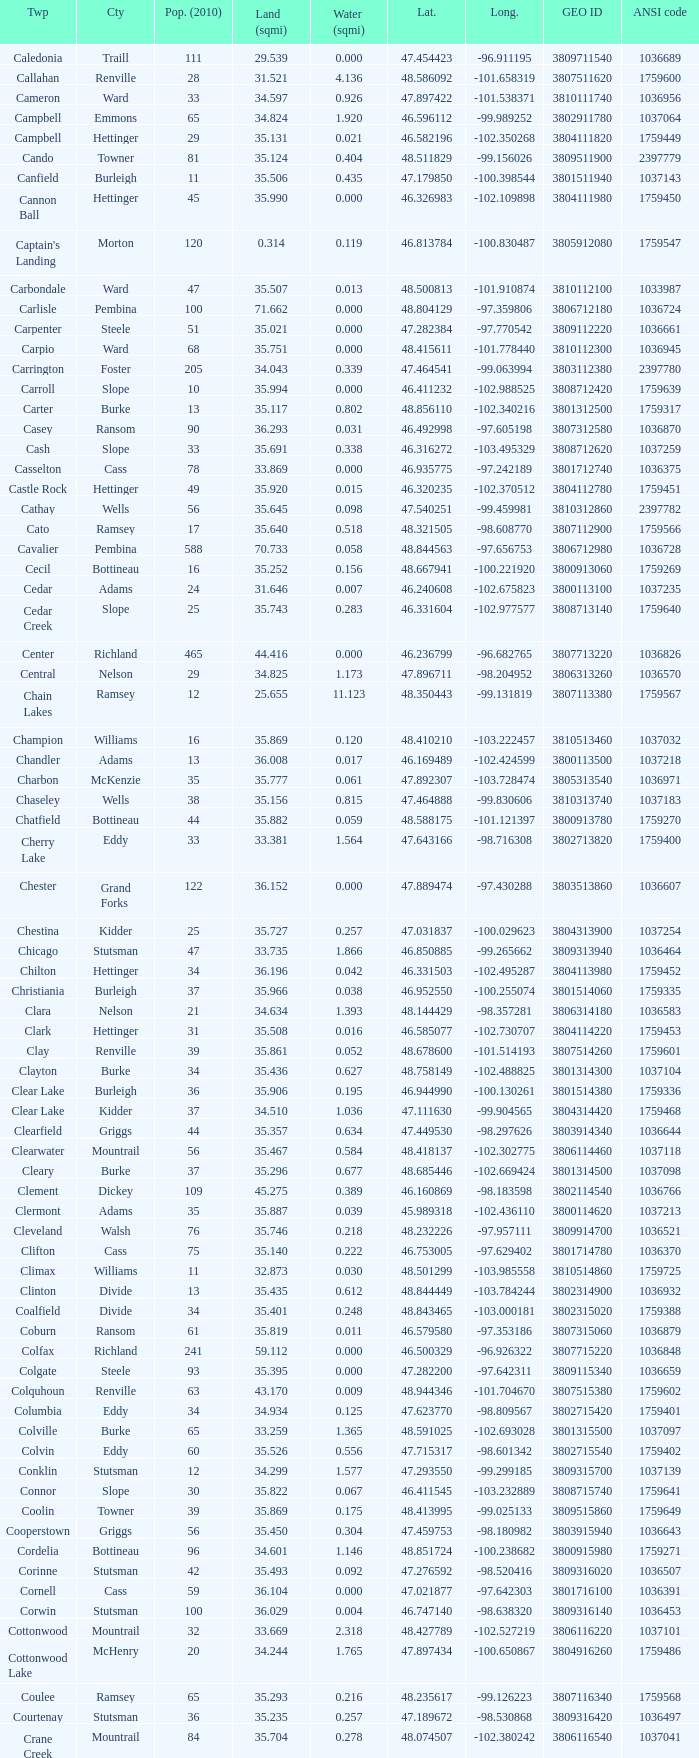What was the latitude of the Clearwater townsship? 48.418137. Give me the full table as a dictionary. {'header': ['Twp', 'Cty', 'Pop. (2010)', 'Land (sqmi)', 'Water (sqmi)', 'Lat.', 'Long.', 'GEO ID', 'ANSI code'], 'rows': [['Caledonia', 'Traill', '111', '29.539', '0.000', '47.454423', '-96.911195', '3809711540', '1036689'], ['Callahan', 'Renville', '28', '31.521', '4.136', '48.586092', '-101.658319', '3807511620', '1759600'], ['Cameron', 'Ward', '33', '34.597', '0.926', '47.897422', '-101.538371', '3810111740', '1036956'], ['Campbell', 'Emmons', '65', '34.824', '1.920', '46.596112', '-99.989252', '3802911780', '1037064'], ['Campbell', 'Hettinger', '29', '35.131', '0.021', '46.582196', '-102.350268', '3804111820', '1759449'], ['Cando', 'Towner', '81', '35.124', '0.404', '48.511829', '-99.156026', '3809511900', '2397779'], ['Canfield', 'Burleigh', '11', '35.506', '0.435', '47.179850', '-100.398544', '3801511940', '1037143'], ['Cannon Ball', 'Hettinger', '45', '35.990', '0.000', '46.326983', '-102.109898', '3804111980', '1759450'], ["Captain's Landing", 'Morton', '120', '0.314', '0.119', '46.813784', '-100.830487', '3805912080', '1759547'], ['Carbondale', 'Ward', '47', '35.507', '0.013', '48.500813', '-101.910874', '3810112100', '1033987'], ['Carlisle', 'Pembina', '100', '71.662', '0.000', '48.804129', '-97.359806', '3806712180', '1036724'], ['Carpenter', 'Steele', '51', '35.021', '0.000', '47.282384', '-97.770542', '3809112220', '1036661'], ['Carpio', 'Ward', '68', '35.751', '0.000', '48.415611', '-101.778440', '3810112300', '1036945'], ['Carrington', 'Foster', '205', '34.043', '0.339', '47.464541', '-99.063994', '3803112380', '2397780'], ['Carroll', 'Slope', '10', '35.994', '0.000', '46.411232', '-102.988525', '3808712420', '1759639'], ['Carter', 'Burke', '13', '35.117', '0.802', '48.856110', '-102.340216', '3801312500', '1759317'], ['Casey', 'Ransom', '90', '36.293', '0.031', '46.492998', '-97.605198', '3807312580', '1036870'], ['Cash', 'Slope', '33', '35.691', '0.338', '46.316272', '-103.495329', '3808712620', '1037259'], ['Casselton', 'Cass', '78', '33.869', '0.000', '46.935775', '-97.242189', '3801712740', '1036375'], ['Castle Rock', 'Hettinger', '49', '35.920', '0.015', '46.320235', '-102.370512', '3804112780', '1759451'], ['Cathay', 'Wells', '56', '35.645', '0.098', '47.540251', '-99.459981', '3810312860', '2397782'], ['Cato', 'Ramsey', '17', '35.640', '0.518', '48.321505', '-98.608770', '3807112900', '1759566'], ['Cavalier', 'Pembina', '588', '70.733', '0.058', '48.844563', '-97.656753', '3806712980', '1036728'], ['Cecil', 'Bottineau', '16', '35.252', '0.156', '48.667941', '-100.221920', '3800913060', '1759269'], ['Cedar', 'Adams', '24', '31.646', '0.007', '46.240608', '-102.675823', '3800113100', '1037235'], ['Cedar Creek', 'Slope', '25', '35.743', '0.283', '46.331604', '-102.977577', '3808713140', '1759640'], ['Center', 'Richland', '465', '44.416', '0.000', '46.236799', '-96.682765', '3807713220', '1036826'], ['Central', 'Nelson', '29', '34.825', '1.173', '47.896711', '-98.204952', '3806313260', '1036570'], ['Chain Lakes', 'Ramsey', '12', '25.655', '11.123', '48.350443', '-99.131819', '3807113380', '1759567'], ['Champion', 'Williams', '16', '35.869', '0.120', '48.410210', '-103.222457', '3810513460', '1037032'], ['Chandler', 'Adams', '13', '36.008', '0.017', '46.169489', '-102.424599', '3800113500', '1037218'], ['Charbon', 'McKenzie', '35', '35.777', '0.061', '47.892307', '-103.728474', '3805313540', '1036971'], ['Chaseley', 'Wells', '38', '35.156', '0.815', '47.464888', '-99.830606', '3810313740', '1037183'], ['Chatfield', 'Bottineau', '44', '35.882', '0.059', '48.588175', '-101.121397', '3800913780', '1759270'], ['Cherry Lake', 'Eddy', '33', '33.381', '1.564', '47.643166', '-98.716308', '3802713820', '1759400'], ['Chester', 'Grand Forks', '122', '36.152', '0.000', '47.889474', '-97.430288', '3803513860', '1036607'], ['Chestina', 'Kidder', '25', '35.727', '0.257', '47.031837', '-100.029623', '3804313900', '1037254'], ['Chicago', 'Stutsman', '47', '33.735', '1.866', '46.850885', '-99.265662', '3809313940', '1036464'], ['Chilton', 'Hettinger', '34', '36.196', '0.042', '46.331503', '-102.495287', '3804113980', '1759452'], ['Christiania', 'Burleigh', '37', '35.966', '0.038', '46.952550', '-100.255074', '3801514060', '1759335'], ['Clara', 'Nelson', '21', '34.634', '1.393', '48.144429', '-98.357281', '3806314180', '1036583'], ['Clark', 'Hettinger', '31', '35.508', '0.016', '46.585077', '-102.730707', '3804114220', '1759453'], ['Clay', 'Renville', '39', '35.861', '0.052', '48.678600', '-101.514193', '3807514260', '1759601'], ['Clayton', 'Burke', '34', '35.436', '0.627', '48.758149', '-102.488825', '3801314300', '1037104'], ['Clear Lake', 'Burleigh', '36', '35.906', '0.195', '46.944990', '-100.130261', '3801514380', '1759336'], ['Clear Lake', 'Kidder', '37', '34.510', '1.036', '47.111630', '-99.904565', '3804314420', '1759468'], ['Clearfield', 'Griggs', '44', '35.357', '0.634', '47.449530', '-98.297626', '3803914340', '1036644'], ['Clearwater', 'Mountrail', '56', '35.467', '0.584', '48.418137', '-102.302775', '3806114460', '1037118'], ['Cleary', 'Burke', '37', '35.296', '0.677', '48.685446', '-102.669424', '3801314500', '1037098'], ['Clement', 'Dickey', '109', '45.275', '0.389', '46.160869', '-98.183598', '3802114540', '1036766'], ['Clermont', 'Adams', '35', '35.887', '0.039', '45.989318', '-102.436110', '3800114620', '1037213'], ['Cleveland', 'Walsh', '76', '35.746', '0.218', '48.232226', '-97.957111', '3809914700', '1036521'], ['Clifton', 'Cass', '75', '35.140', '0.222', '46.753005', '-97.629402', '3801714780', '1036370'], ['Climax', 'Williams', '11', '32.873', '0.030', '48.501299', '-103.985558', '3810514860', '1759725'], ['Clinton', 'Divide', '13', '35.435', '0.612', '48.844449', '-103.784244', '3802314900', '1036932'], ['Coalfield', 'Divide', '34', '35.401', '0.248', '48.843465', '-103.000181', '3802315020', '1759388'], ['Coburn', 'Ransom', '61', '35.819', '0.011', '46.579580', '-97.353186', '3807315060', '1036879'], ['Colfax', 'Richland', '241', '59.112', '0.000', '46.500329', '-96.926322', '3807715220', '1036848'], ['Colgate', 'Steele', '93', '35.395', '0.000', '47.282200', '-97.642311', '3809115340', '1036659'], ['Colquhoun', 'Renville', '63', '43.170', '0.009', '48.944346', '-101.704670', '3807515380', '1759602'], ['Columbia', 'Eddy', '34', '34.934', '0.125', '47.623770', '-98.809567', '3802715420', '1759401'], ['Colville', 'Burke', '65', '33.259', '1.365', '48.591025', '-102.693028', '3801315500', '1037097'], ['Colvin', 'Eddy', '60', '35.526', '0.556', '47.715317', '-98.601342', '3802715540', '1759402'], ['Conklin', 'Stutsman', '12', '34.299', '1.577', '47.293550', '-99.299185', '3809315700', '1037139'], ['Connor', 'Slope', '30', '35.822', '0.067', '46.411545', '-103.232889', '3808715740', '1759641'], ['Coolin', 'Towner', '39', '35.869', '0.175', '48.413995', '-99.025133', '3809515860', '1759649'], ['Cooperstown', 'Griggs', '56', '35.450', '0.304', '47.459753', '-98.180982', '3803915940', '1036643'], ['Cordelia', 'Bottineau', '96', '34.601', '1.146', '48.851724', '-100.238682', '3800915980', '1759271'], ['Corinne', 'Stutsman', '42', '35.493', '0.092', '47.276592', '-98.520416', '3809316020', '1036507'], ['Cornell', 'Cass', '59', '36.104', '0.000', '47.021877', '-97.642303', '3801716100', '1036391'], ['Corwin', 'Stutsman', '100', '36.029', '0.004', '46.747140', '-98.638320', '3809316140', '1036453'], ['Cottonwood', 'Mountrail', '32', '33.669', '2.318', '48.427789', '-102.527219', '3806116220', '1037101'], ['Cottonwood Lake', 'McHenry', '20', '34.244', '1.765', '47.897434', '-100.650867', '3804916260', '1759486'], ['Coulee', 'Ramsey', '65', '35.293', '0.216', '48.235617', '-99.126223', '3807116340', '1759568'], ['Courtenay', 'Stutsman', '36', '35.235', '0.257', '47.189672', '-98.530868', '3809316420', '1036497'], ['Crane Creek', 'Mountrail', '84', '35.704', '0.278', '48.074507', '-102.380242', '3806116540', '1037041'], ['Crawford', 'Slope', '31', '35.892', '0.051', '46.320329', '-103.729934', '3808716620', '1037166'], ['Creel', 'Ramsey', '1305', '14.578', '15.621', '48.075823', '-98.857272', '3807116660', '1759569'], ['Cremerville', 'McLean', '27', '35.739', '0.054', '47.811011', '-102.054883', '3805516700', '1759530'], ['Crocus', 'Towner', '44', '35.047', '0.940', '48.667289', '-99.155787', '3809516820', '1759650'], ['Crofte', 'Burleigh', '199', '36.163', '0.000', '47.026425', '-100.685988', '3801516860', '1037131'], ['Cromwell', 'Burleigh', '35', '36.208', '0.000', '47.026008', '-100.558805', '3801516900', '1037133'], ['Crowfoot', 'Mountrail', '18', '34.701', '1.283', '48.495946', '-102.180433', '3806116980', '1037050'], ['Crown Hill', 'Kidder', '7', '30.799', '1.468', '46.770977', '-100.025924', '3804317020', '1759469'], ['Crystal', 'Pembina', '50', '35.499', '0.000', '48.586423', '-97.732145', '3806717100', '1036718'], ['Crystal Lake', 'Wells', '32', '35.522', '0.424', '47.541346', '-99.974737', '3810317140', '1037152'], ['Crystal Springs', 'Kidder', '32', '35.415', '0.636', '46.848792', '-99.529639', '3804317220', '1759470'], ['Cuba', 'Barnes', '76', '35.709', '0.032', '46.851144', '-97.860271', '3800317300', '1036409'], ['Cusator', 'Stutsman', '26', '34.878', '0.693', '46.746853', '-98.997611', '3809317460', '1036459'], ['Cut Bank', 'Bottineau', '37', '35.898', '0.033', '48.763937', '-101.430571', '3800917540', '1759272']]} 